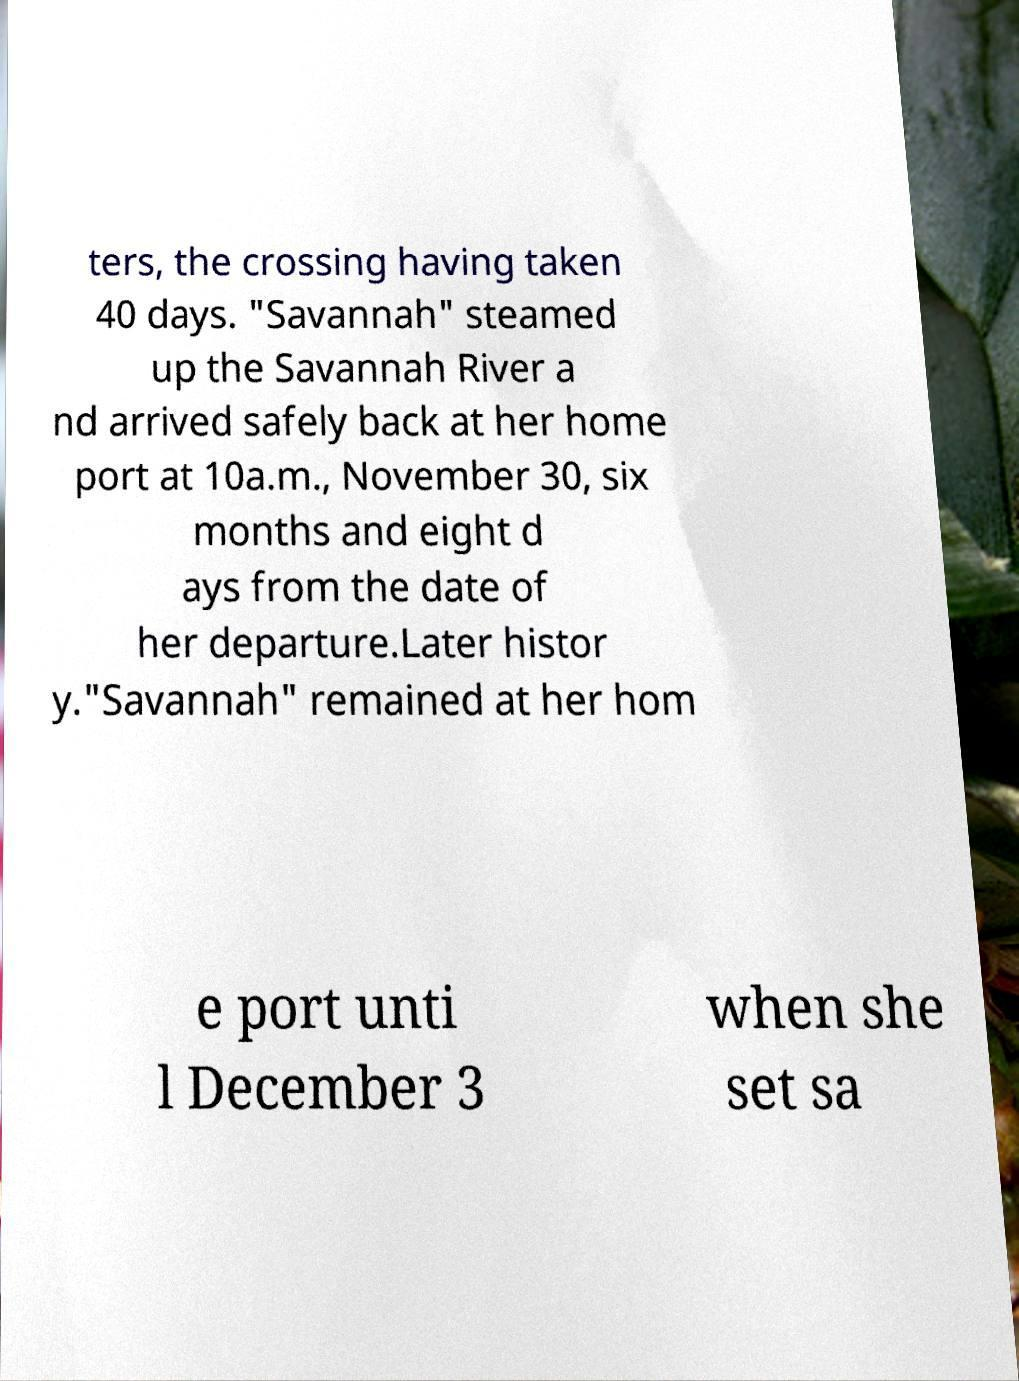Could you assist in decoding the text presented in this image and type it out clearly? ters, the crossing having taken 40 days. "Savannah" steamed up the Savannah River a nd arrived safely back at her home port at 10a.m., November 30, six months and eight d ays from the date of her departure.Later histor y."Savannah" remained at her hom e port unti l December 3 when she set sa 